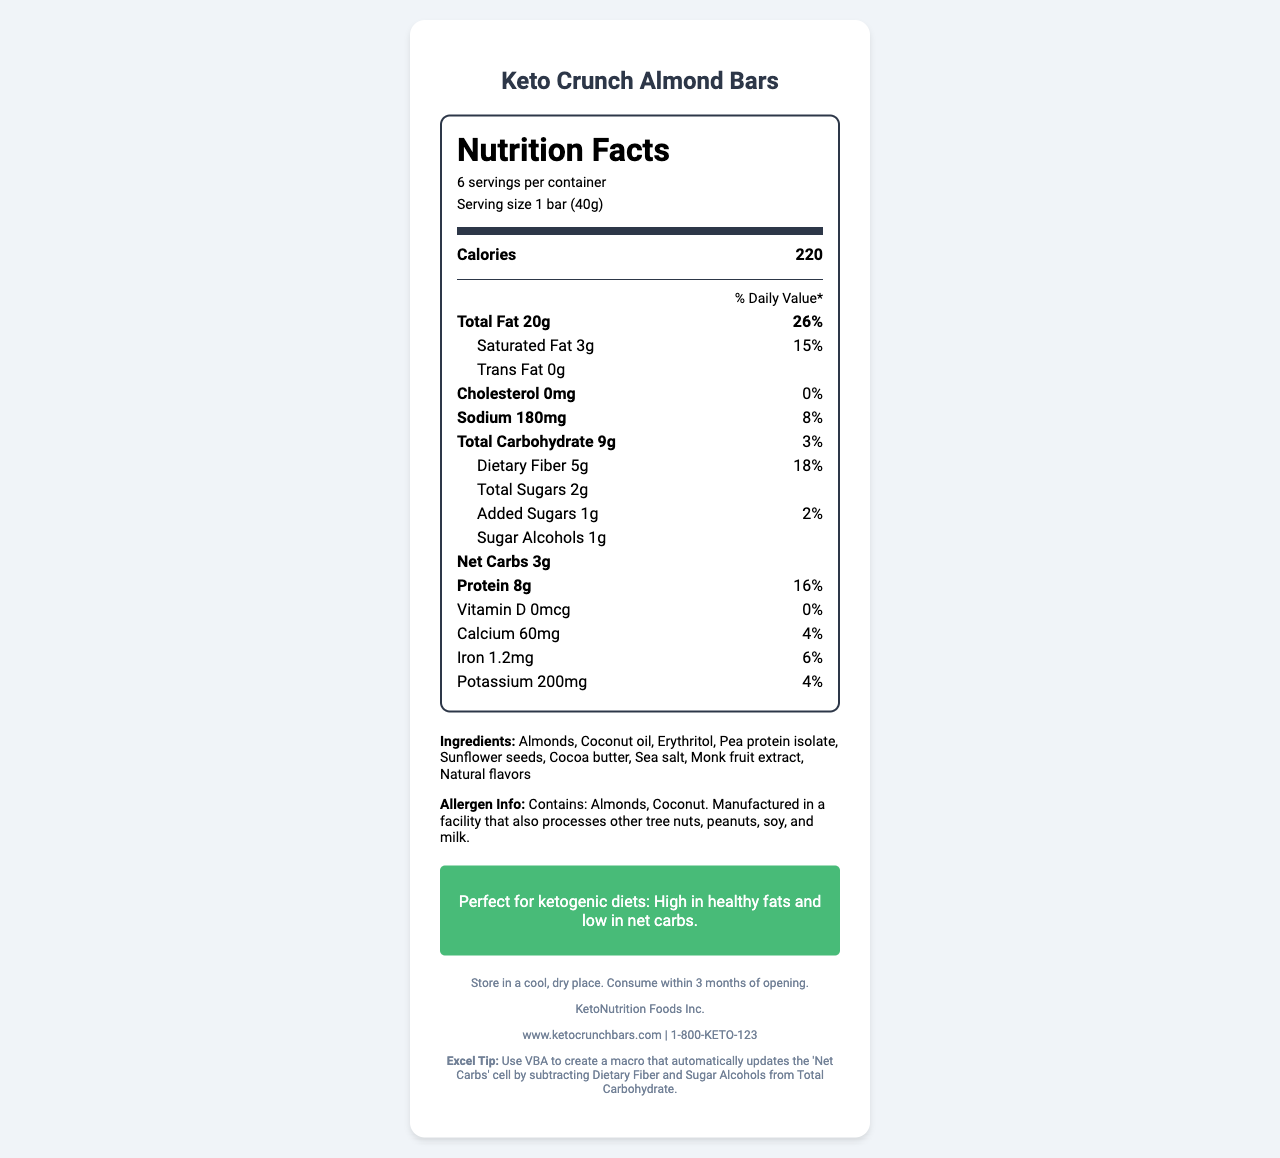what is the serving size of the Keto Crunch Almond Bars? The serving size is stated in the document as "1 bar (40g)".
Answer: 1 bar (40g) how many calories are in one serving? The document mentions that one serving of Keto Crunch Almond Bars contains 220 calories.
Answer: 220 calories how much total fat is in one bar, and what is its daily value percentage? The document states that the total fat content is 20g, which is 26% of the daily value.
Answer: 20g, 26% what is the amount of dietary fiber per serving? The dietary fiber content per serving listed in the document is 5g.
Answer: 5g what are the allergens mentioned? The allergen information in the document indicates that the bars contain Almonds and Coconut.
Answer: Almonds, Coconut how many grams of net carbs are in one bar? The document specifies that there are 3g of net carbs in one bar.
Answer: 3g how much protein is in each serving, and what is its daily value percentage? Each serving contains 8g of protein, which constitutes 16% of the daily value.
Answer: 8g, 16% is there any cholesterol in the Keto Crunch Almond Bars? Yes/No The document states that the cholesterol content is 0mg, which means there is no cholesterol.
Answer: No which of the following statements is true about the vitamins and minerals in Keto Crunch Almond Bars?
 I. Contains Vitamin D
 II. Contains Calcium
 III. High in Iron The document specifies that the bars contain Calcium (60mg, 4%) and Iron (1.2mg, 6%) but do not contain Vitamin D (0%).
Answer: II and III which ingredient is not present in the Keto Crunch Almond Bars? A. Almonds B. Coconut oil C. Peanuts D. Monk fruit extract The document lists the ingredients and mentions "Manufactured in a facility that processes peanuts" but does not list peanuts as an ingredient.
Answer: C are the snacks suitable for a ketogenic diet? True/False The document includes a statement "Perfect for ketogenic diets: High in healthy fats and low in net carbs."
Answer: True summarize the main nutritional content of the Keto Crunch Almond Bars. The Keto Crunch Almond Bars are described as being high in healthy fats (20g total fat), providing a moderate amount of protein (8g), and having low net carbs (3g), making them suitable for ketogenic diets.
Answer: High in fat, moderate protein, low net carbs what is the exact amount of added sugars per bar? The document states that there is 1g of added sugars per bar.
Answer: 1g how many bars are in one container? The document mentions there are 6 servings per container, with each serving being one bar.
Answer: 6 how much potassium is in one serving? The potassium content per serving is listed as 200mg in the document.
Answer: 200mg how long should the product be consumed after opening? The storage instructions advise to consume the product within 3 months of opening.
Answer: Within 3 months is the product gluten-free? The document does not provide any information regarding whether the product is gluten-free.
Answer: Not enough information 